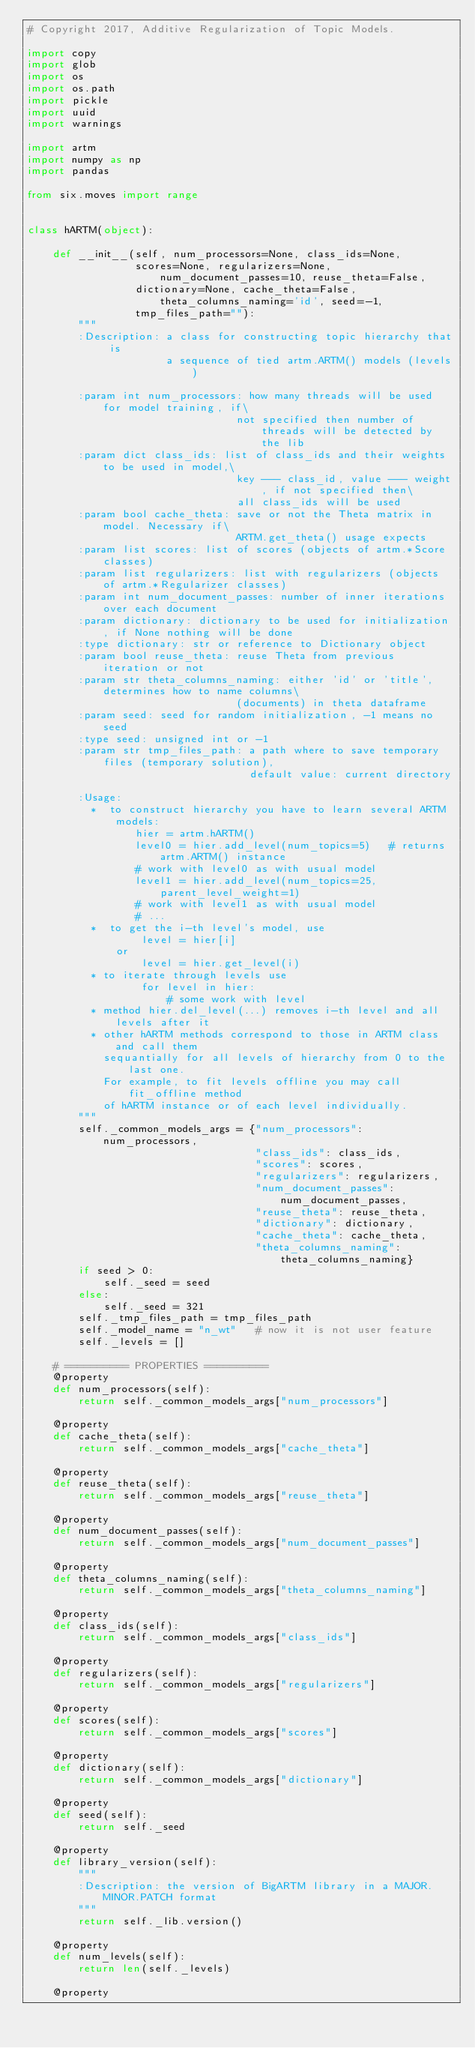<code> <loc_0><loc_0><loc_500><loc_500><_Python_># Copyright 2017, Additive Regularization of Topic Models.

import copy
import glob
import os
import os.path
import pickle
import uuid
import warnings

import artm
import numpy as np
import pandas

from six.moves import range


class hARTM(object):

    def __init__(self, num_processors=None, class_ids=None,
                 scores=None, regularizers=None, num_document_passes=10, reuse_theta=False,
                 dictionary=None, cache_theta=False, theta_columns_naming='id', seed=-1,
                 tmp_files_path=""):
        """
        :Description: a class for constructing topic hierarchy that is
                      a sequence of tied artm.ARTM() models (levels)

        :param int num_processors: how many threads will be used for model training, if\
                                 not specified then number of threads will be detected by the lib
        :param dict class_ids: list of class_ids and their weights to be used in model,\
                                 key --- class_id, value --- weight, if not specified then\
                                 all class_ids will be used
        :param bool cache_theta: save or not the Theta matrix in model. Necessary if\
                                 ARTM.get_theta() usage expects
        :param list scores: list of scores (objects of artm.*Score classes)
        :param list regularizers: list with regularizers (objects of artm.*Regularizer classes)
        :param int num_document_passes: number of inner iterations over each document
        :param dictionary: dictionary to be used for initialization, if None nothing will be done
        :type dictionary: str or reference to Dictionary object
        :param bool reuse_theta: reuse Theta from previous iteration or not
        :param str theta_columns_naming: either 'id' or 'title', determines how to name columns\
                                 (documents) in theta dataframe
        :param seed: seed for random initialization, -1 means no seed
        :type seed: unsigned int or -1
        :param str tmp_files_path: a path where to save temporary files (temporary solution),
                                   default value: current directory

        :Usage:
          *  to construct hierarchy you have to learn several ARTM models:
                 hier = artm.hARTM()
                 level0 = hier.add_level(num_topics=5)   # returns artm.ARTM() instance
                 # work with level0 as with usual model
                 level1 = hier.add_level(num_topics=25, parent_level_weight=1)
                 # work with level1 as with usual model
                 # ...
          *  to get the i-th level's model, use
                  level = hier[i]
              or
                  level = hier.get_level(i)
          * to iterate through levels use
                  for level in hier:
                      # some work with level
          * method hier.del_level(...) removes i-th level and all levels after it
          * other hARTM methods correspond to those in ARTM class and call them
            sequantially for all levels of hierarchy from 0 to the last one.
            For example, to fit levels offline you may call fit_offline method
            of hARTM instance or of each level individually.
        """
        self._common_models_args = {"num_processors": num_processors,
                                    "class_ids": class_ids,
                                    "scores": scores,
                                    "regularizers": regularizers,
                                    "num_document_passes": num_document_passes,
                                    "reuse_theta": reuse_theta,
                                    "dictionary": dictionary,
                                    "cache_theta": cache_theta,
                                    "theta_columns_naming": theta_columns_naming}
        if seed > 0:
            self._seed = seed
        else:
            self._seed = 321
        self._tmp_files_path = tmp_files_path
        self._model_name = "n_wt"   # now it is not user feature
        self._levels = []

    # ========== PROPERTIES ==========
    @property
    def num_processors(self):
        return self._common_models_args["num_processors"]

    @property
    def cache_theta(self):
        return self._common_models_args["cache_theta"]

    @property
    def reuse_theta(self):
        return self._common_models_args["reuse_theta"]

    @property
    def num_document_passes(self):
        return self._common_models_args["num_document_passes"]

    @property
    def theta_columns_naming(self):
        return self._common_models_args["theta_columns_naming"]

    @property
    def class_ids(self):
        return self._common_models_args["class_ids"]

    @property
    def regularizers(self):
        return self._common_models_args["regularizers"]

    @property
    def scores(self):
        return self._common_models_args["scores"]

    @property
    def dictionary(self):
        return self._common_models_args["dictionary"]

    @property
    def seed(self):
        return self._seed

    @property
    def library_version(self):
        """
        :Description: the version of BigARTM library in a MAJOR.MINOR.PATCH format
        """
        return self._lib.version()

    @property
    def num_levels(self):
        return len(self._levels)

    @property</code> 